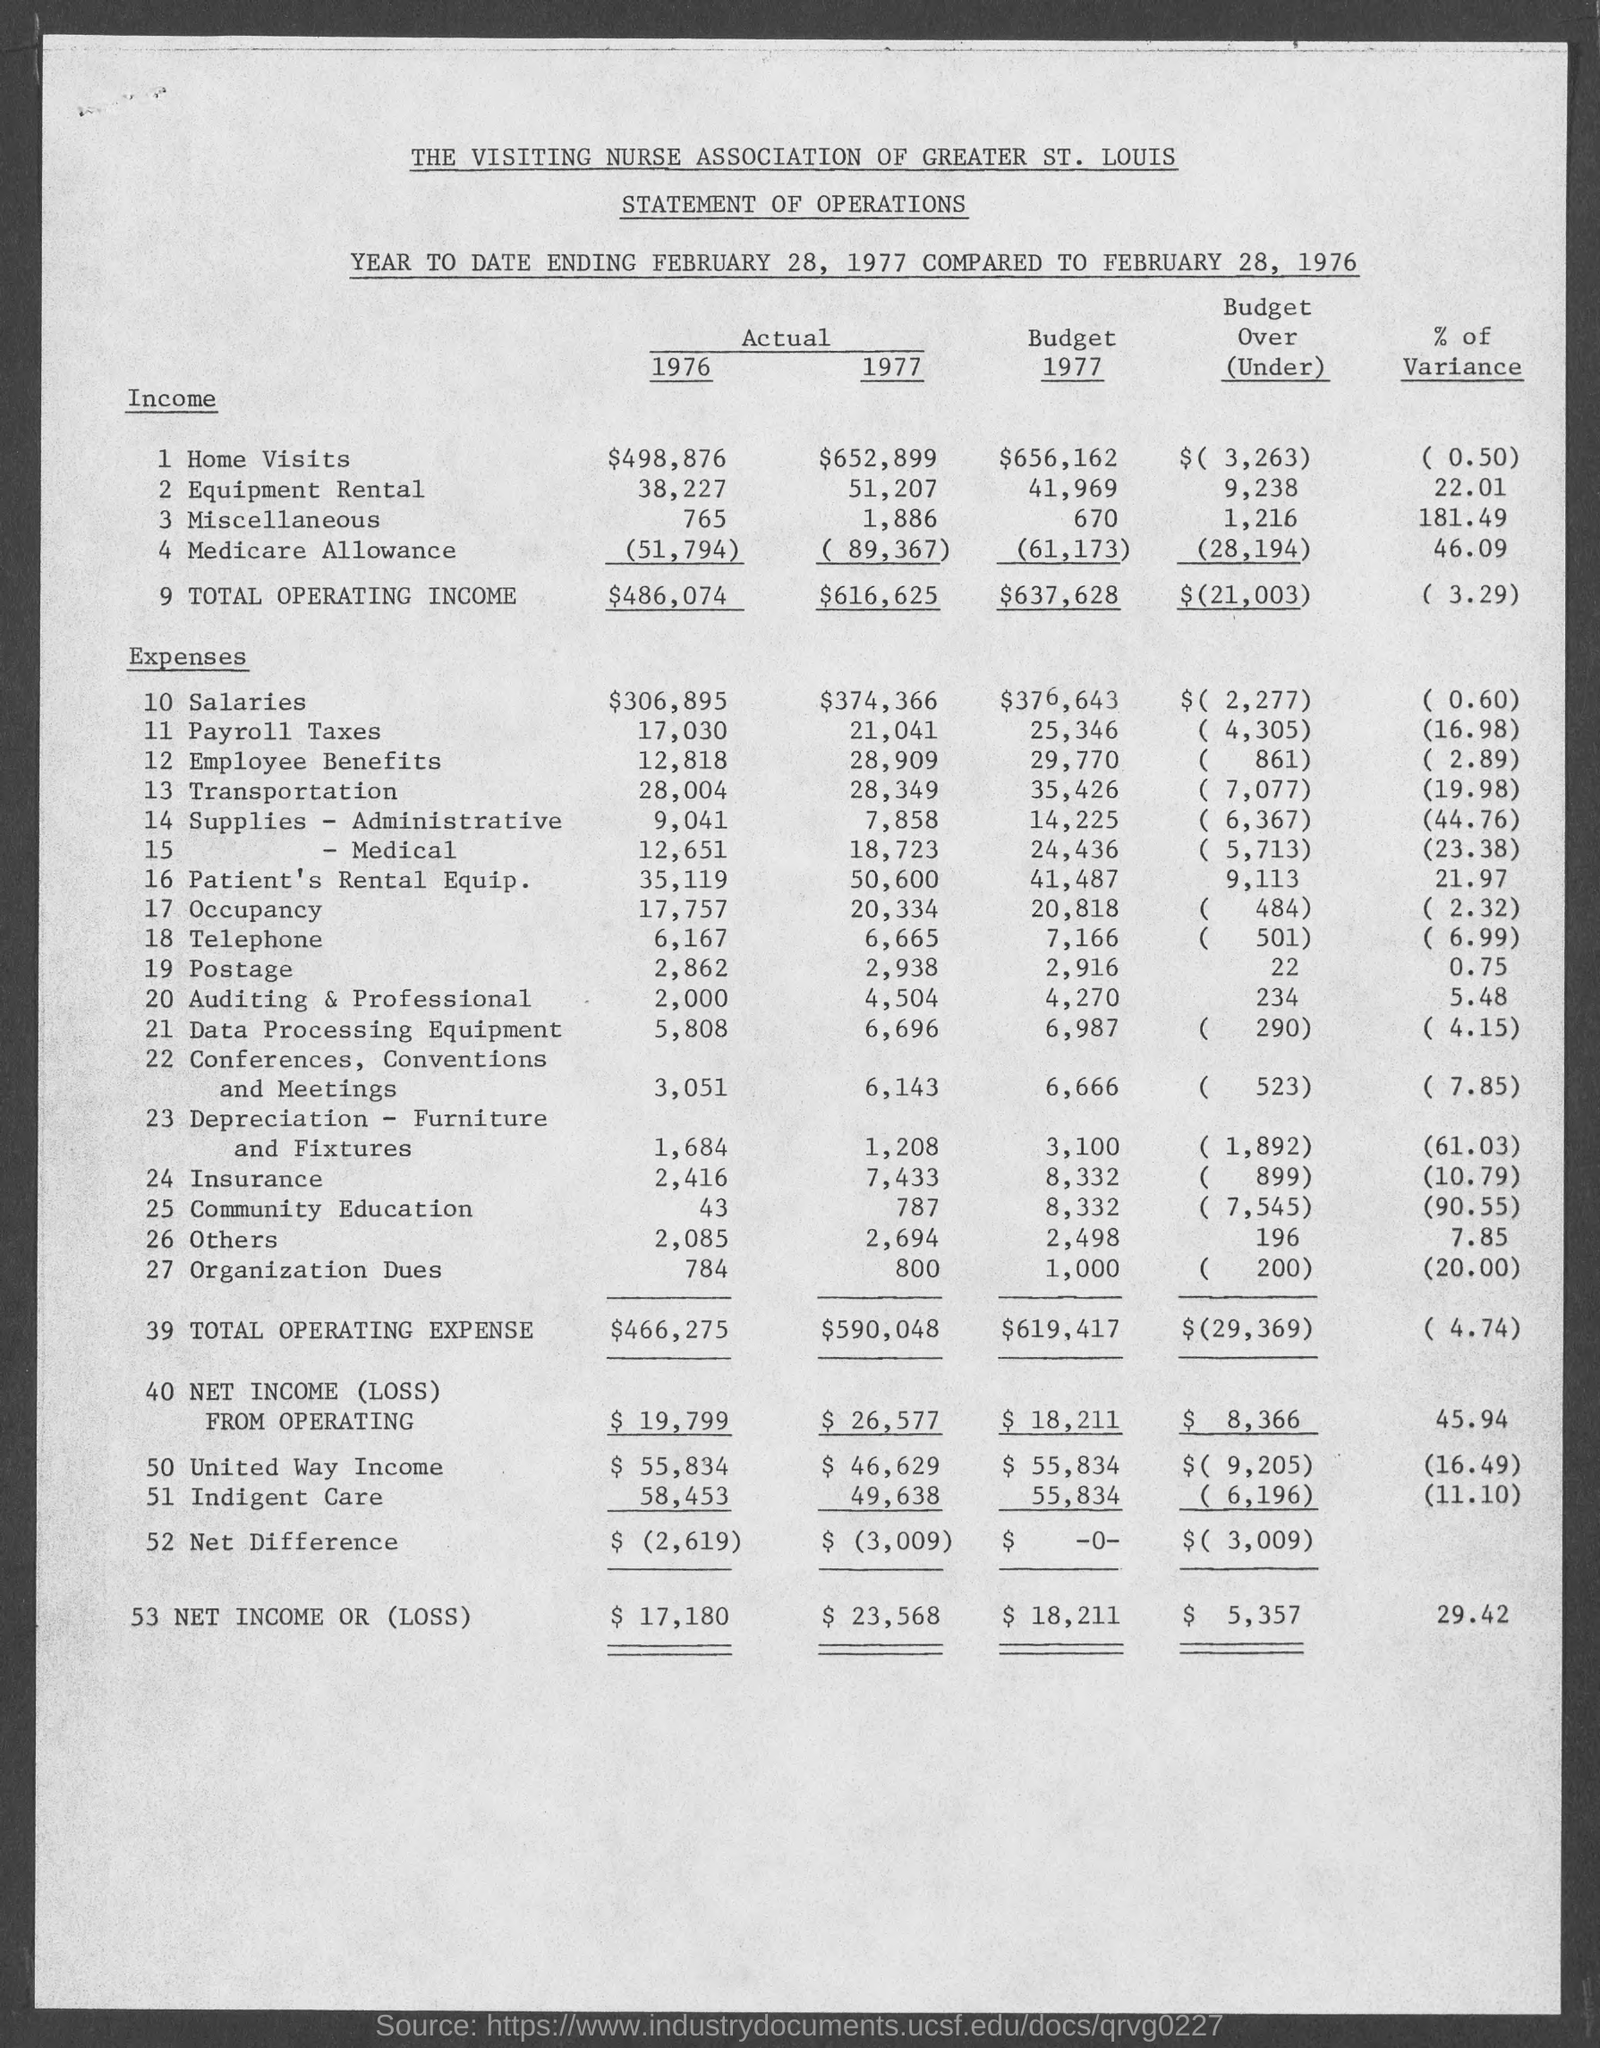Give some essential details in this illustration. The actual income for miscellaneous in 1976 was $765. In 1976, the actual income for Medicare allowance was $51,794. The actual income for home visits in 1977 was $652,899. In 1977, the actual income for miscellaneous expenses was 1,886. The total operating income for the year 1976 was $486,074. 